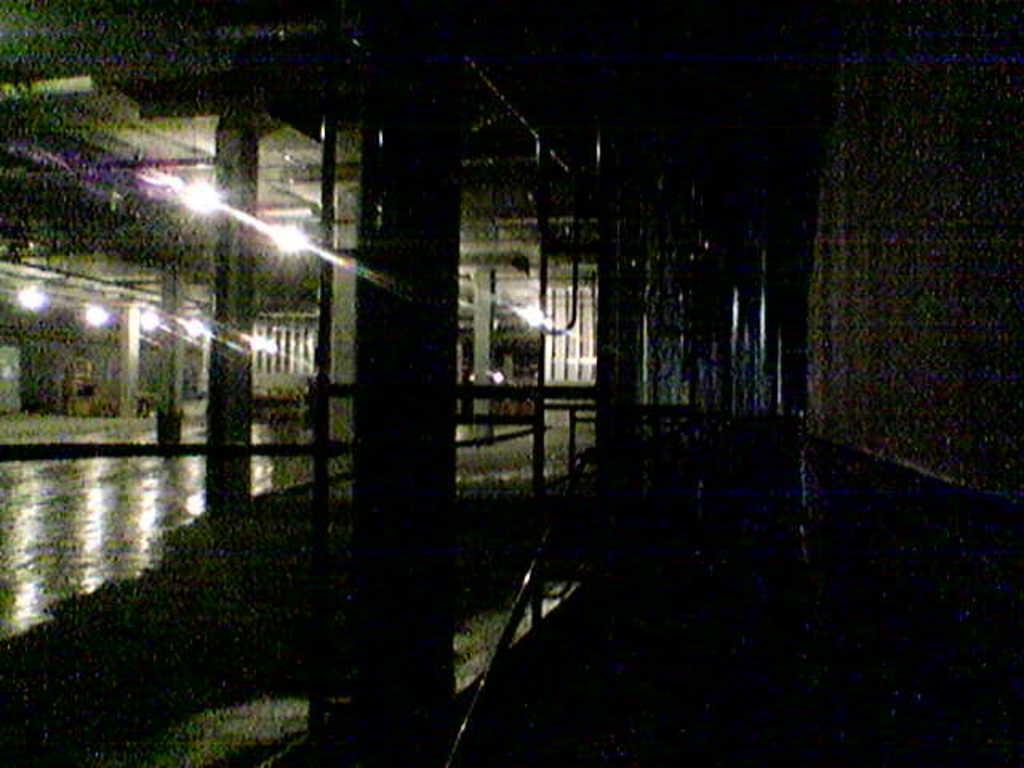How would you summarize this image in a sentence or two? In this dark and blurry image there is a wall. There are lights to the ceiling. In the center there is a pillar. Beside the pillar there is a railing. 